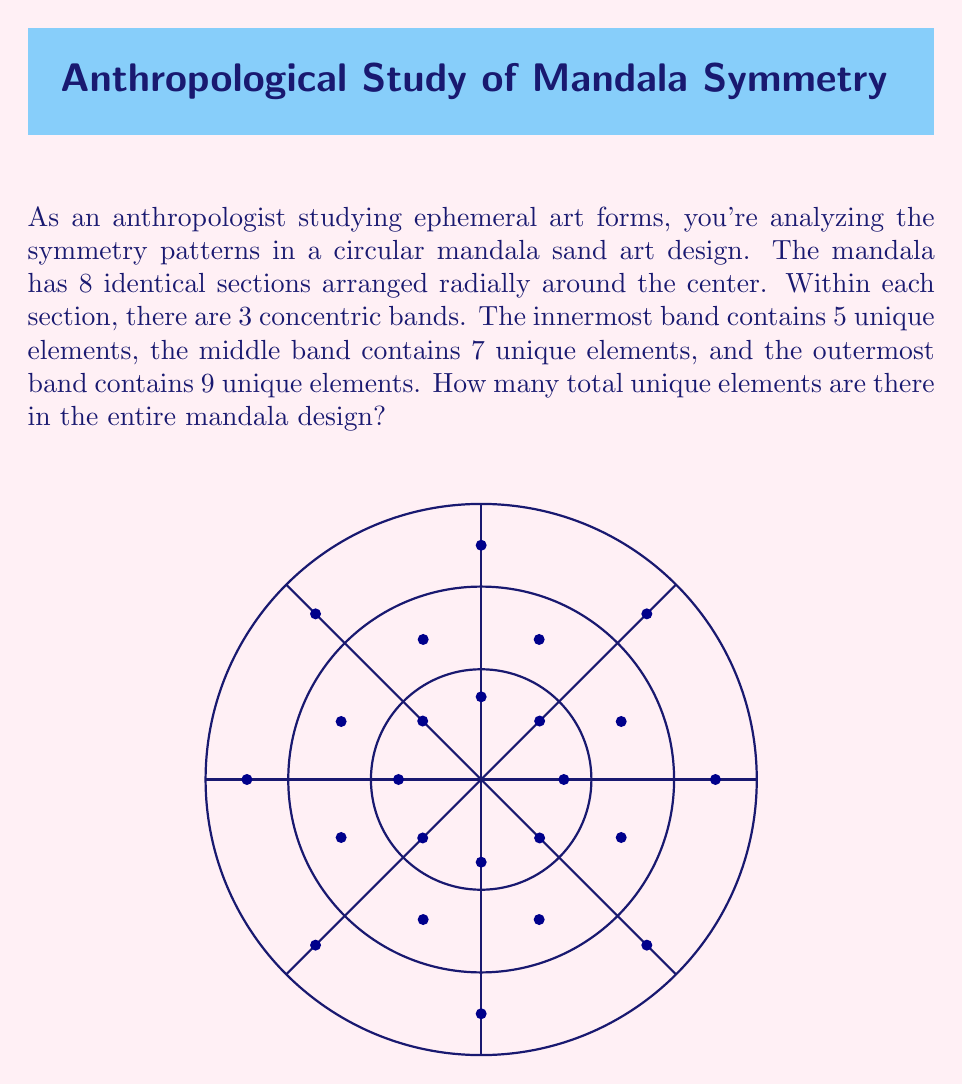Could you help me with this problem? Let's break this down step-by-step:

1) First, we need to understand the structure of the mandala:
   - It has 8 identical sections
   - Each section has 3 concentric bands
   - The bands contain 5, 7, and 9 unique elements respectively

2) Since the sections are identical, we only need to count the unique elements in one section:
   - Innermost band: 5 elements
   - Middle band: 7 elements
   - Outermost band: 9 elements

3) To find the total number of unique elements in one section, we add these together:
   $$5 + 7 + 9 = 21$$

4) Now, we might be tempted to multiply this by 8 (the number of sections), but that would be incorrect. Remember, these elements are repeated in each section, so we don't count them multiple times.

5) Therefore, the total number of unique elements in the entire mandala is simply the number of unique elements in one section: 21.

This analysis reflects the nature of mandala designs, where patterns are repeated symmetrically around a central point, creating a complex whole from a set of repeated elements.
Answer: 21 unique elements 